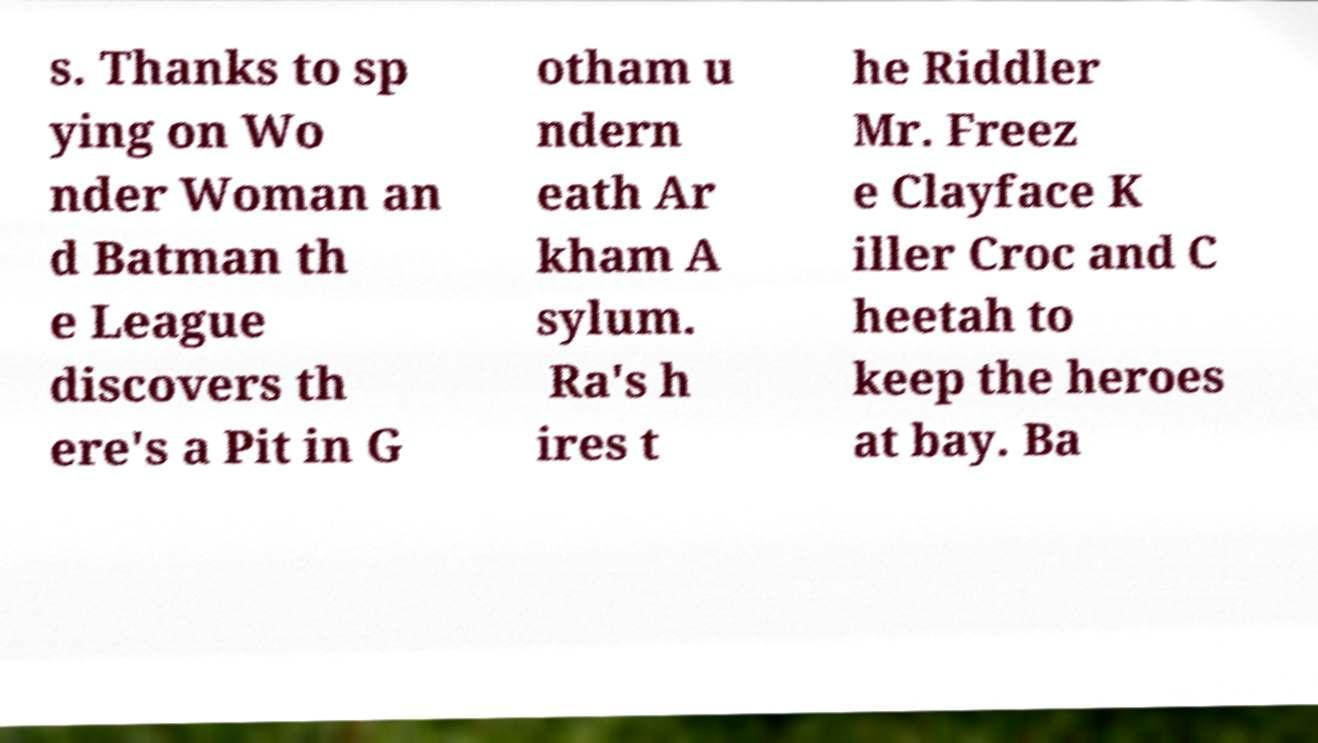Could you extract and type out the text from this image? s. Thanks to sp ying on Wo nder Woman an d Batman th e League discovers th ere's a Pit in G otham u ndern eath Ar kham A sylum. Ra's h ires t he Riddler Mr. Freez e Clayface K iller Croc and C heetah to keep the heroes at bay. Ba 